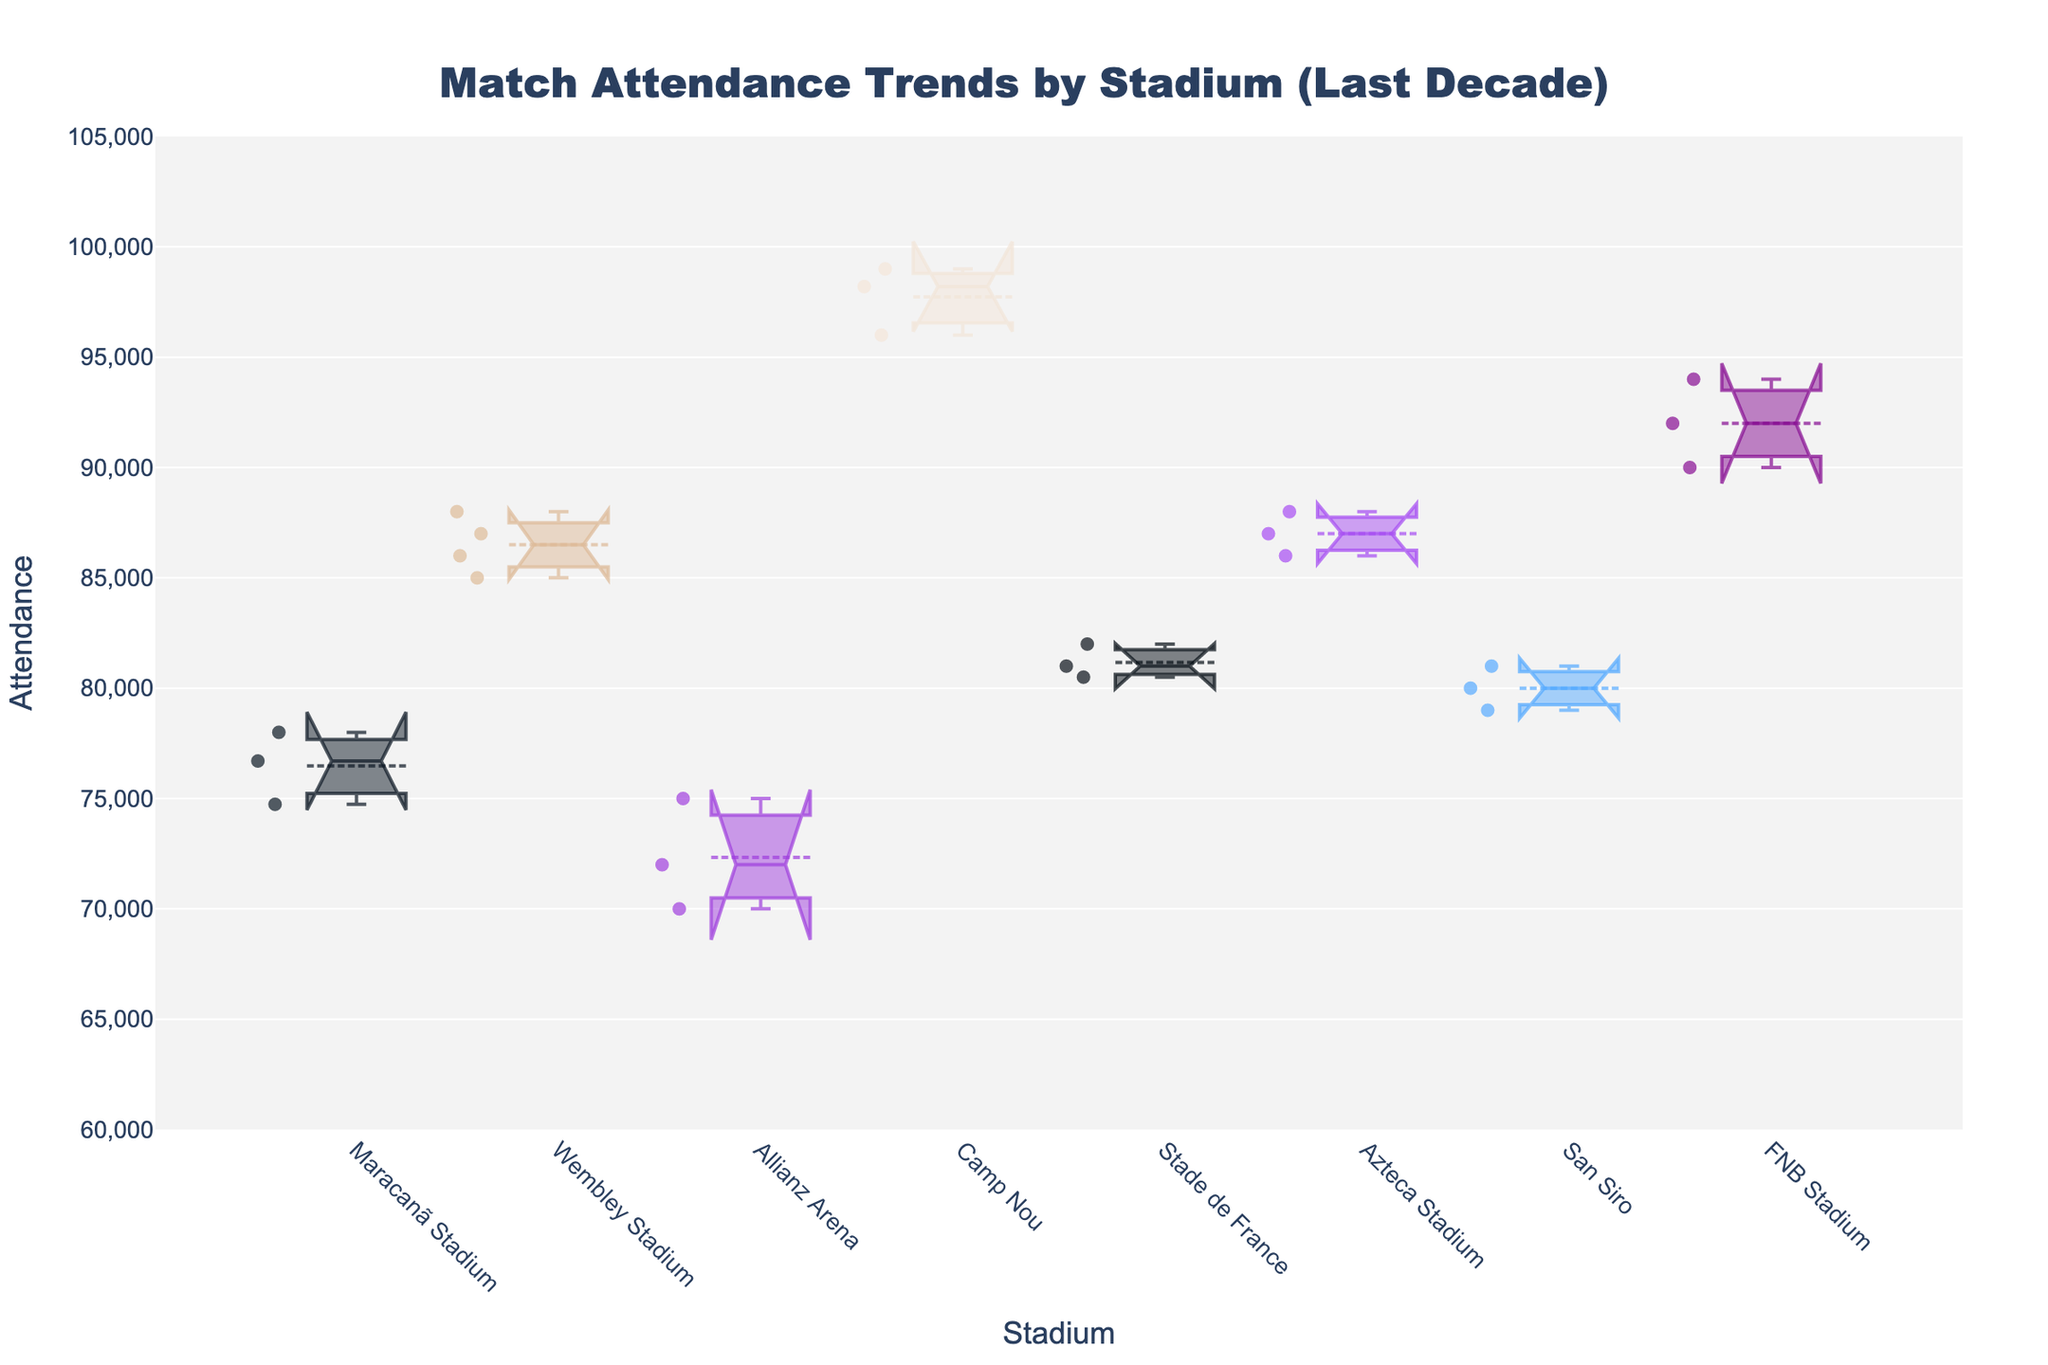What is the title of the figure? The title of the figure is located at the top and provides a concise description of the content being presented in the plot. By reading it, we understand that the plot shows attendance trends in different stadiums over the past decade.
Answer: Match Attendance Trends by Stadium (Last Decade) What is the y-axis label? The y-axis label is positioned vertically along the left side of the plot and informs us about the variable being measured on that axis. Here, it specifies that the vertical axis represents attendance numbers.
Answer: Attendance Which stadium has the highest median attendance? To determine which stadium has the highest median attendance, we look at the central notch of each box. The highest notch, representing the median, indicates the stadium with the largest median attendance. Wembley Stadium has the highest-notch positioning among all the stadiums shown.
Answer: Wembley Stadium How does the attendance at FNB Stadium compare to the attendance at Camp Nou? To compare the attendance at FNB Stadium and Camp Nou, we examine the notches and the spread of the box plots for both. Camp Nou has higher attendance numbers on average, with median values significantly above those of FNB Stadium, whose values are lower but substantial.
Answer: Camp Nou has higher attendance Which stadium has the widest range in attendance values? We need to look at the length of the whiskers of each box plot, which represents the range from the minimum to the maximum observed values. A longer whisker indicates a wider range in attendance. Camp Nou's data shows the most extended whiskers, indicating the broadest range in attendance values.
Answer: Camp Nou What is the median attendance for matches held at Maracanã Stadium? To find the median attendance, we locate the central notch of the Maracanã Stadium's box plot, which represents the middle value of the dataset. The median attendance at Maracanã Stadium, based on the notch, appears to be approximately 76,700.
Answer: ~76,700 Which two stadiums have the closest median attendances? We look for notches that are positioned similarly along the y-axis. The notches for the Stade de France and Maracanã Stadium appear to be closest to each other, indicating very similar median attendances.
Answer: Stade de France and Maracanã Stadium Is there a stadium where attendances appear to be decreasing over time? By examining the general trending of data points in the box plots and noting the years provided, we can infer if there is a downtrend. While not directly indicated on a notched box plot, potential decreases might be inferred through deeper individual year analysis. FNB Stadium shows a slight decrease over time within the plot data.
Answer: FNB Stadium Which stadium has relatively consistent attendance figures over the years? To determine consistency, seek the box plot with the smallest interquartile range (the distance between the first and third quartiles), and minimal spread in the whiskers. Wembley Stadium’s box plot shows minimal spread and a consistently high median, indicating consistent attendance.
Answer: Wembley Stadium 